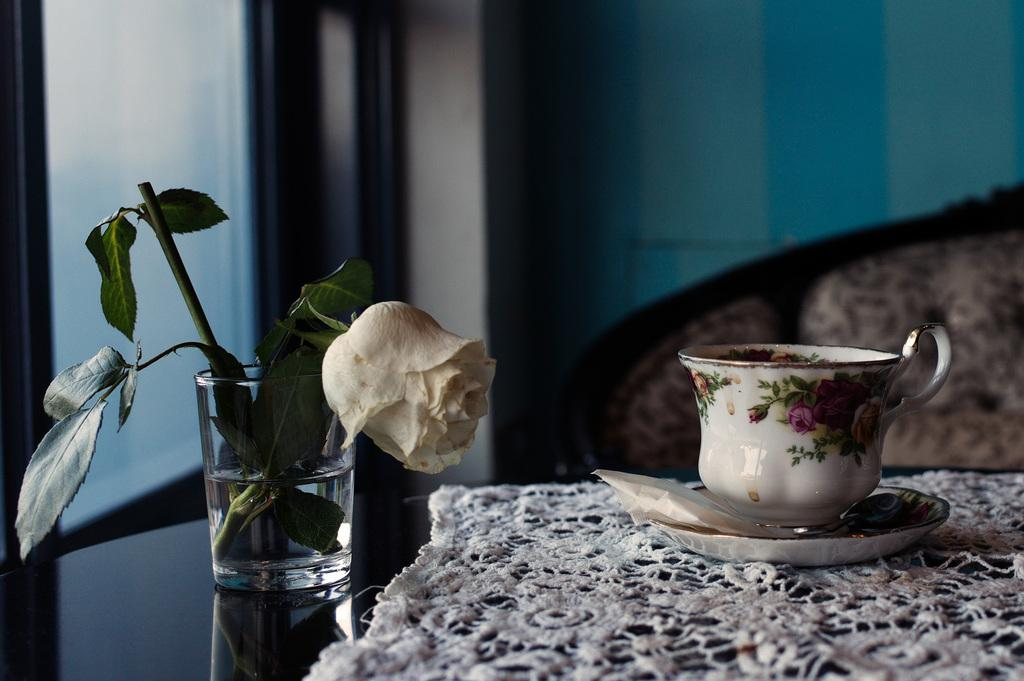What is in the glass that is visible in the image? There is a glass of water with a flower in the image. What is on the table in the image? There is a cloth, a saucer, and a cup on the table in the image. What piece of furniture is in front of the table? There is a couch in front of the table. What is beside the table in the image? There is a window beside the table. What type of clouds can be seen through the window in the image? There are no clouds visible through the window in the image. What is the vein pattern on the saucer in the image? There is no mention of a vein pattern on the saucer in the provided facts, and the image does not show any such detail. 